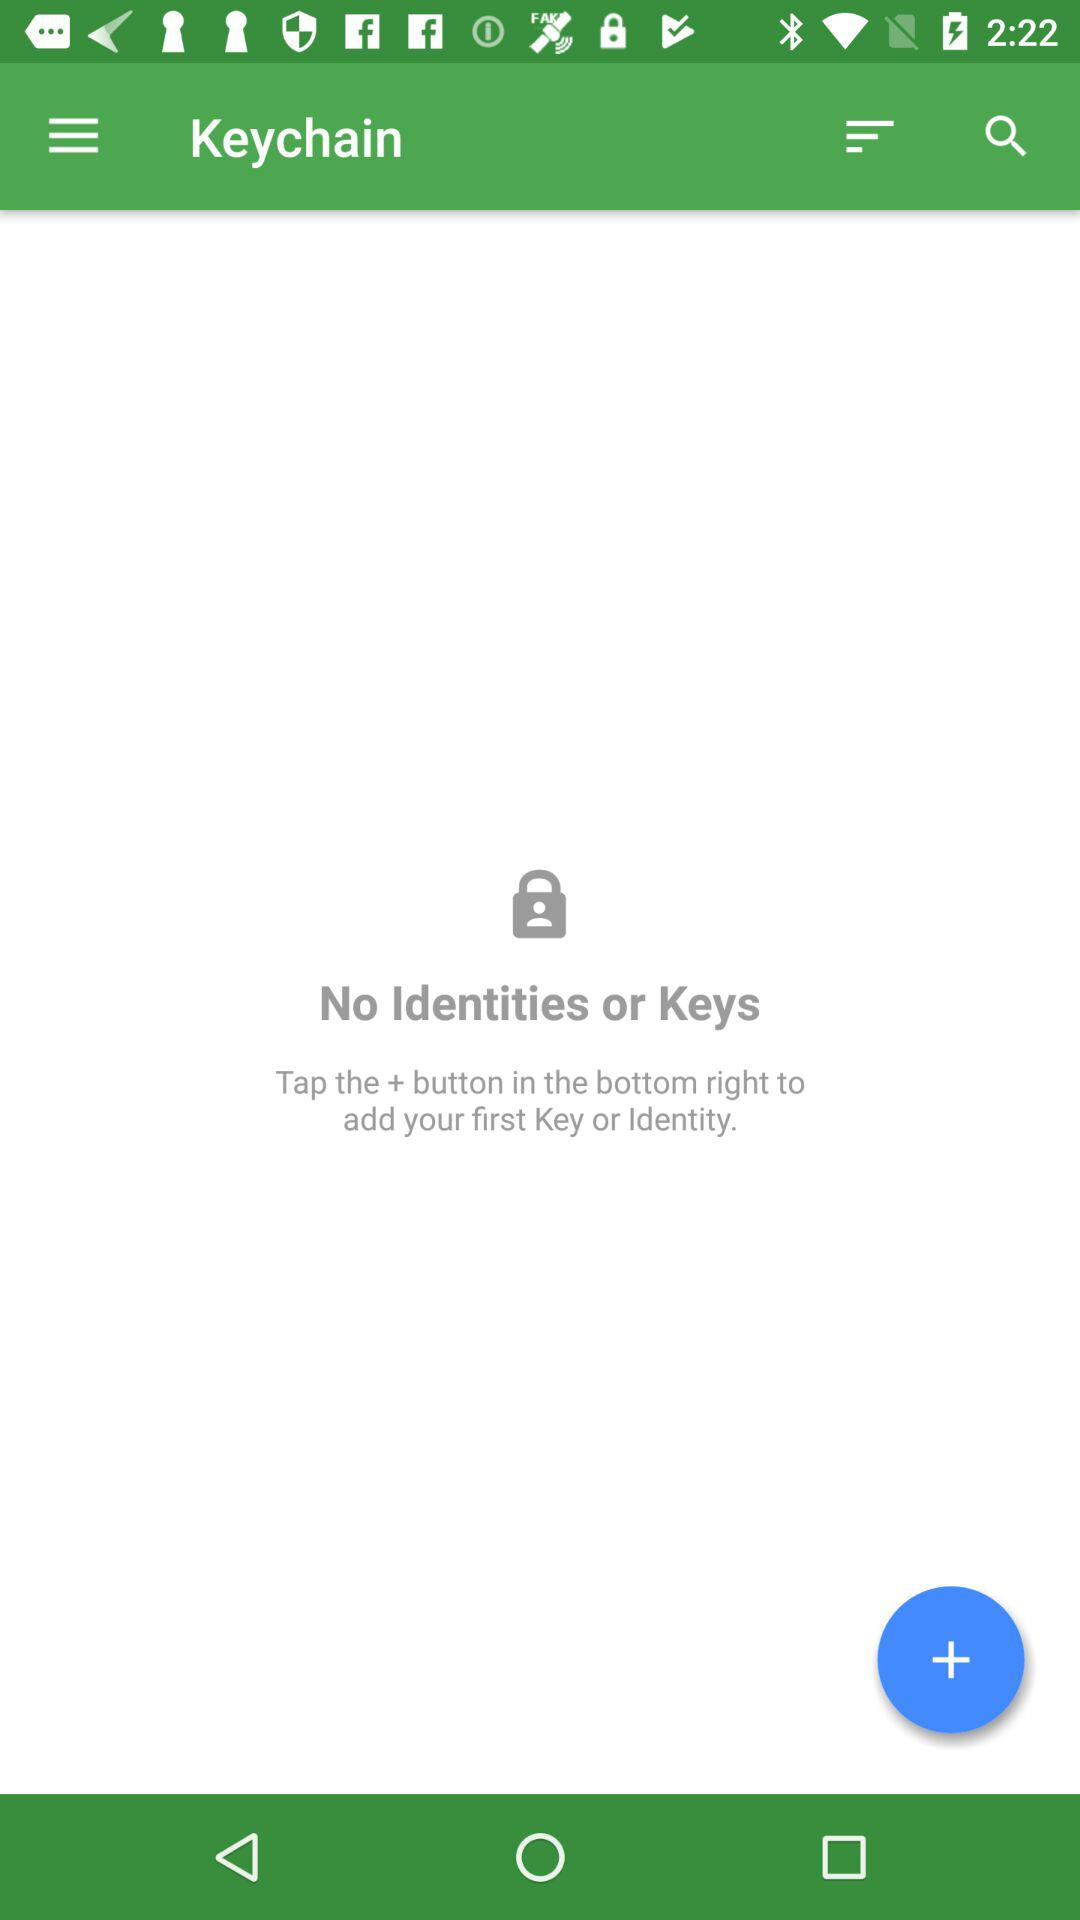How many keys are there? There are no keys. 